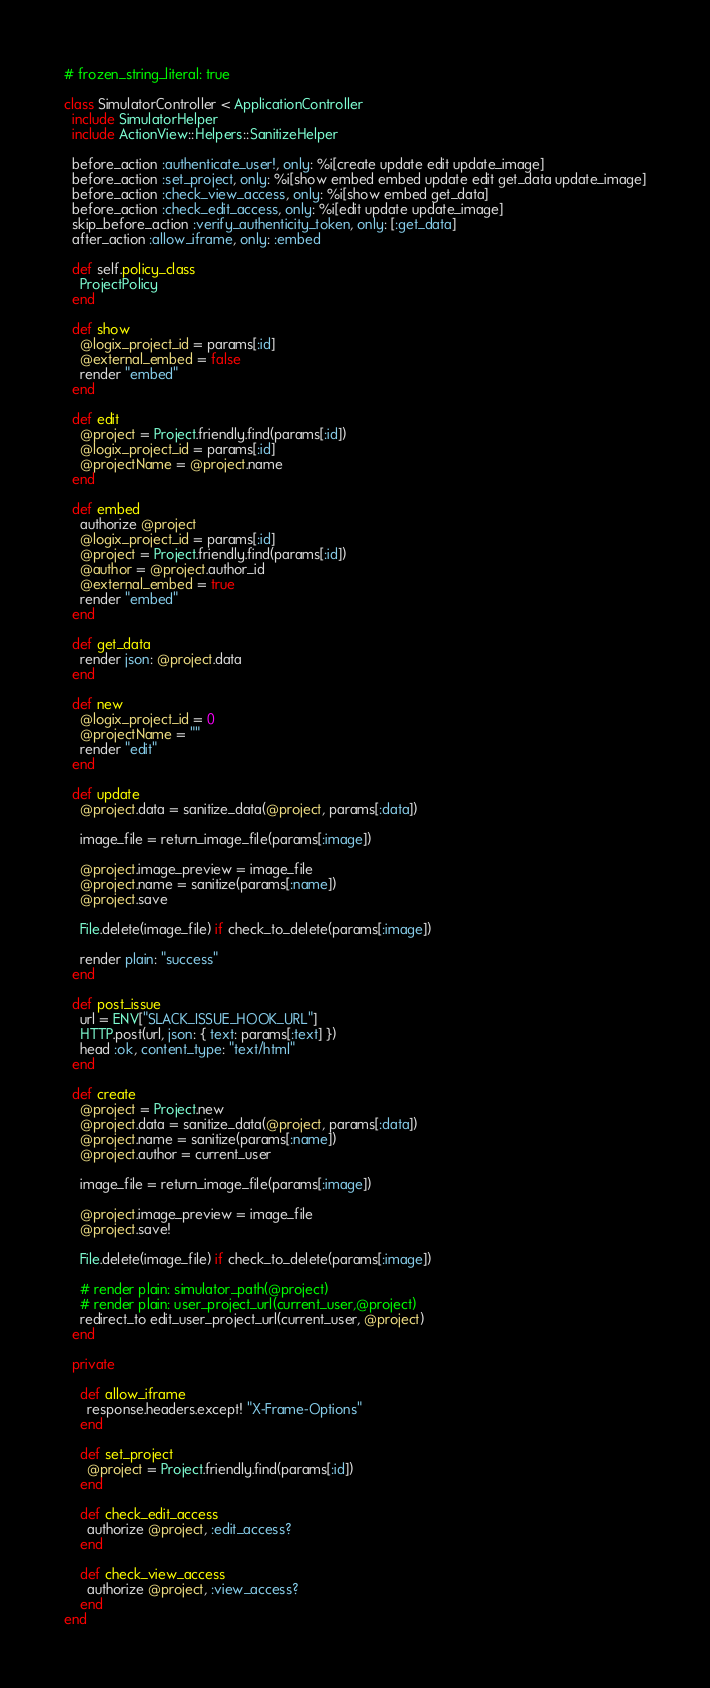Convert code to text. <code><loc_0><loc_0><loc_500><loc_500><_Ruby_># frozen_string_literal: true

class SimulatorController < ApplicationController
  include SimulatorHelper
  include ActionView::Helpers::SanitizeHelper

  before_action :authenticate_user!, only: %i[create update edit update_image]
  before_action :set_project, only: %i[show embed embed update edit get_data update_image]
  before_action :check_view_access, only: %i[show embed get_data]
  before_action :check_edit_access, only: %i[edit update update_image]
  skip_before_action :verify_authenticity_token, only: [:get_data]
  after_action :allow_iframe, only: :embed

  def self.policy_class
    ProjectPolicy
  end

  def show
    @logix_project_id = params[:id]
    @external_embed = false
    render "embed"
  end

  def edit
    @project = Project.friendly.find(params[:id])
    @logix_project_id = params[:id]
    @projectName = @project.name
  end

  def embed
    authorize @project
    @logix_project_id = params[:id]
    @project = Project.friendly.find(params[:id])
    @author = @project.author_id
    @external_embed = true
    render "embed"
  end

  def get_data
    render json: @project.data
  end

  def new
    @logix_project_id = 0
    @projectName = ""
    render "edit"
  end

  def update
    @project.data = sanitize_data(@project, params[:data])

    image_file = return_image_file(params[:image])

    @project.image_preview = image_file
    @project.name = sanitize(params[:name])
    @project.save

    File.delete(image_file) if check_to_delete(params[:image])

    render plain: "success"
  end

  def post_issue
    url = ENV["SLACK_ISSUE_HOOK_URL"]
    HTTP.post(url, json: { text: params[:text] })
    head :ok, content_type: "text/html"
  end

  def create
    @project = Project.new
    @project.data = sanitize_data(@project, params[:data])
    @project.name = sanitize(params[:name])
    @project.author = current_user

    image_file = return_image_file(params[:image])

    @project.image_preview = image_file
    @project.save!

    File.delete(image_file) if check_to_delete(params[:image])

    # render plain: simulator_path(@project)
    # render plain: user_project_url(current_user,@project)
    redirect_to edit_user_project_url(current_user, @project)
  end

  private

    def allow_iframe
      response.headers.except! "X-Frame-Options"
    end

    def set_project
      @project = Project.friendly.find(params[:id])
    end

    def check_edit_access
      authorize @project, :edit_access?
    end

    def check_view_access
      authorize @project, :view_access?
    end
end
</code> 